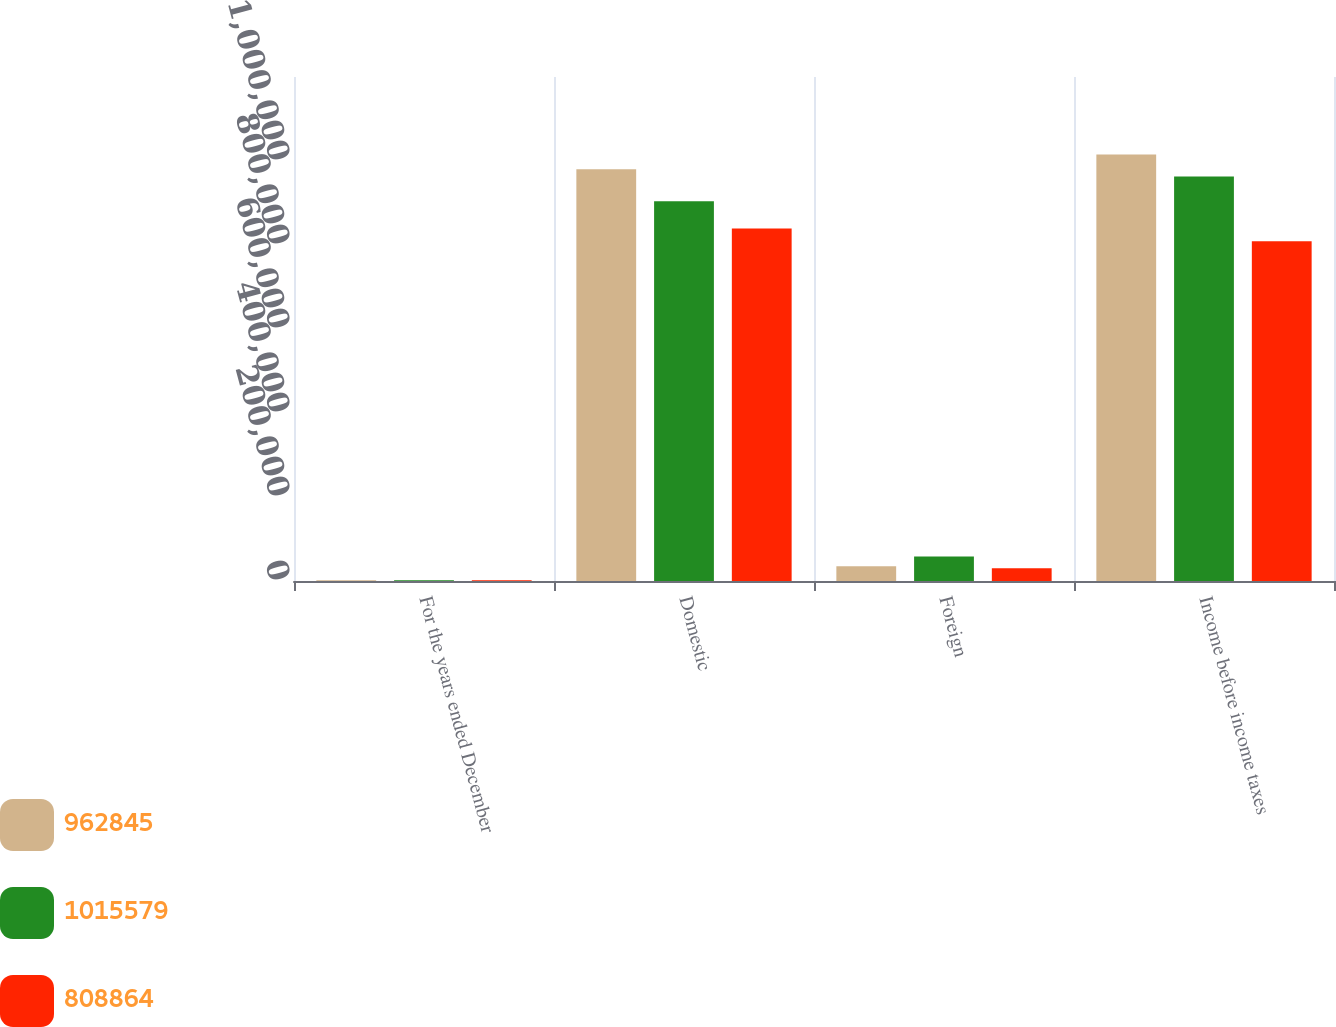Convert chart. <chart><loc_0><loc_0><loc_500><loc_500><stacked_bar_chart><ecel><fcel>For the years ended December<fcel>Domestic<fcel>Foreign<fcel>Income before income taxes<nl><fcel>962845<fcel>2012<fcel>980176<fcel>35403<fcel>1.01558e+06<nl><fcel>1.01558e+06<fcel>2011<fcel>904418<fcel>58427<fcel>962845<nl><fcel>808864<fcel>2010<fcel>839012<fcel>30148<fcel>808864<nl></chart> 